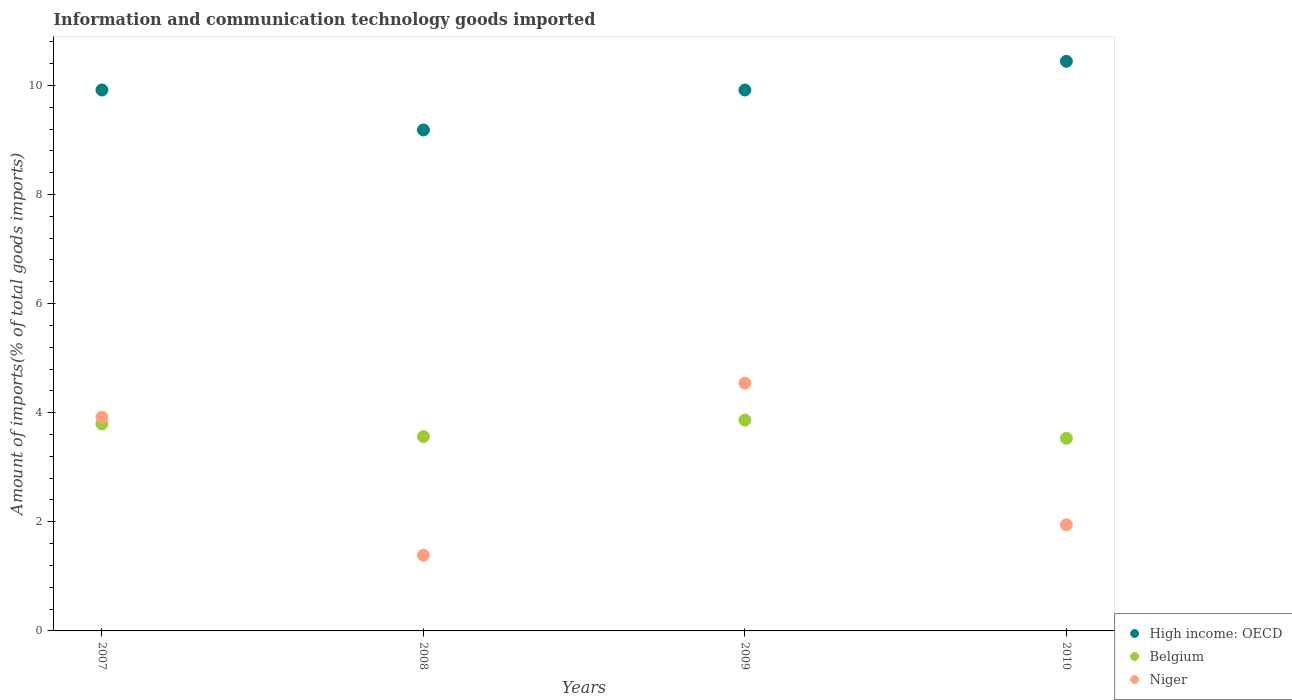How many different coloured dotlines are there?
Your answer should be very brief. 3. What is the amount of goods imported in Niger in 2008?
Ensure brevity in your answer.  1.39. Across all years, what is the maximum amount of goods imported in Niger?
Your answer should be compact. 4.54. Across all years, what is the minimum amount of goods imported in Belgium?
Provide a short and direct response. 3.53. In which year was the amount of goods imported in Belgium minimum?
Your answer should be compact. 2010. What is the total amount of goods imported in High income: OECD in the graph?
Make the answer very short. 39.46. What is the difference between the amount of goods imported in Niger in 2008 and that in 2010?
Make the answer very short. -0.56. What is the difference between the amount of goods imported in Niger in 2010 and the amount of goods imported in Belgium in 2007?
Keep it short and to the point. -1.85. What is the average amount of goods imported in Niger per year?
Ensure brevity in your answer.  2.95. In the year 2007, what is the difference between the amount of goods imported in High income: OECD and amount of goods imported in Belgium?
Your response must be concise. 6.12. In how many years, is the amount of goods imported in Belgium greater than 8.4 %?
Your response must be concise. 0. What is the ratio of the amount of goods imported in High income: OECD in 2007 to that in 2008?
Make the answer very short. 1.08. What is the difference between the highest and the second highest amount of goods imported in High income: OECD?
Keep it short and to the point. 0.53. What is the difference between the highest and the lowest amount of goods imported in Niger?
Your answer should be very brief. 3.15. Is the sum of the amount of goods imported in Belgium in 2007 and 2009 greater than the maximum amount of goods imported in High income: OECD across all years?
Ensure brevity in your answer.  No. Is it the case that in every year, the sum of the amount of goods imported in High income: OECD and amount of goods imported in Niger  is greater than the amount of goods imported in Belgium?
Your answer should be compact. Yes. Does the amount of goods imported in High income: OECD monotonically increase over the years?
Offer a very short reply. No. Is the amount of goods imported in Belgium strictly less than the amount of goods imported in High income: OECD over the years?
Ensure brevity in your answer.  Yes. What is the difference between two consecutive major ticks on the Y-axis?
Your response must be concise. 2. Are the values on the major ticks of Y-axis written in scientific E-notation?
Make the answer very short. No. Does the graph contain any zero values?
Your answer should be very brief. No. Where does the legend appear in the graph?
Offer a very short reply. Bottom right. How many legend labels are there?
Offer a terse response. 3. What is the title of the graph?
Keep it short and to the point. Information and communication technology goods imported. Does "Colombia" appear as one of the legend labels in the graph?
Offer a terse response. No. What is the label or title of the X-axis?
Your response must be concise. Years. What is the label or title of the Y-axis?
Offer a terse response. Amount of imports(% of total goods imports). What is the Amount of imports(% of total goods imports) in High income: OECD in 2007?
Your answer should be very brief. 9.92. What is the Amount of imports(% of total goods imports) of Belgium in 2007?
Offer a terse response. 3.79. What is the Amount of imports(% of total goods imports) in Niger in 2007?
Make the answer very short. 3.91. What is the Amount of imports(% of total goods imports) in High income: OECD in 2008?
Make the answer very short. 9.18. What is the Amount of imports(% of total goods imports) in Belgium in 2008?
Provide a short and direct response. 3.56. What is the Amount of imports(% of total goods imports) in Niger in 2008?
Give a very brief answer. 1.39. What is the Amount of imports(% of total goods imports) in High income: OECD in 2009?
Your answer should be very brief. 9.92. What is the Amount of imports(% of total goods imports) of Belgium in 2009?
Your answer should be compact. 3.87. What is the Amount of imports(% of total goods imports) of Niger in 2009?
Give a very brief answer. 4.54. What is the Amount of imports(% of total goods imports) of High income: OECD in 2010?
Your answer should be very brief. 10.44. What is the Amount of imports(% of total goods imports) in Belgium in 2010?
Provide a succinct answer. 3.53. What is the Amount of imports(% of total goods imports) in Niger in 2010?
Make the answer very short. 1.95. Across all years, what is the maximum Amount of imports(% of total goods imports) of High income: OECD?
Provide a succinct answer. 10.44. Across all years, what is the maximum Amount of imports(% of total goods imports) in Belgium?
Your answer should be compact. 3.87. Across all years, what is the maximum Amount of imports(% of total goods imports) in Niger?
Your response must be concise. 4.54. Across all years, what is the minimum Amount of imports(% of total goods imports) in High income: OECD?
Provide a short and direct response. 9.18. Across all years, what is the minimum Amount of imports(% of total goods imports) in Belgium?
Keep it short and to the point. 3.53. Across all years, what is the minimum Amount of imports(% of total goods imports) of Niger?
Provide a succinct answer. 1.39. What is the total Amount of imports(% of total goods imports) in High income: OECD in the graph?
Keep it short and to the point. 39.45. What is the total Amount of imports(% of total goods imports) of Belgium in the graph?
Your response must be concise. 14.75. What is the total Amount of imports(% of total goods imports) in Niger in the graph?
Make the answer very short. 11.79. What is the difference between the Amount of imports(% of total goods imports) in High income: OECD in 2007 and that in 2008?
Your response must be concise. 0.73. What is the difference between the Amount of imports(% of total goods imports) of Belgium in 2007 and that in 2008?
Provide a short and direct response. 0.23. What is the difference between the Amount of imports(% of total goods imports) in Niger in 2007 and that in 2008?
Give a very brief answer. 2.53. What is the difference between the Amount of imports(% of total goods imports) in Belgium in 2007 and that in 2009?
Ensure brevity in your answer.  -0.07. What is the difference between the Amount of imports(% of total goods imports) in Niger in 2007 and that in 2009?
Your answer should be very brief. -0.63. What is the difference between the Amount of imports(% of total goods imports) in High income: OECD in 2007 and that in 2010?
Ensure brevity in your answer.  -0.53. What is the difference between the Amount of imports(% of total goods imports) of Belgium in 2007 and that in 2010?
Ensure brevity in your answer.  0.26. What is the difference between the Amount of imports(% of total goods imports) of Niger in 2007 and that in 2010?
Ensure brevity in your answer.  1.97. What is the difference between the Amount of imports(% of total goods imports) of High income: OECD in 2008 and that in 2009?
Your response must be concise. -0.73. What is the difference between the Amount of imports(% of total goods imports) in Belgium in 2008 and that in 2009?
Ensure brevity in your answer.  -0.3. What is the difference between the Amount of imports(% of total goods imports) in Niger in 2008 and that in 2009?
Ensure brevity in your answer.  -3.15. What is the difference between the Amount of imports(% of total goods imports) in High income: OECD in 2008 and that in 2010?
Offer a very short reply. -1.26. What is the difference between the Amount of imports(% of total goods imports) of Belgium in 2008 and that in 2010?
Your answer should be very brief. 0.03. What is the difference between the Amount of imports(% of total goods imports) of Niger in 2008 and that in 2010?
Give a very brief answer. -0.56. What is the difference between the Amount of imports(% of total goods imports) in High income: OECD in 2009 and that in 2010?
Make the answer very short. -0.53. What is the difference between the Amount of imports(% of total goods imports) of Belgium in 2009 and that in 2010?
Ensure brevity in your answer.  0.33. What is the difference between the Amount of imports(% of total goods imports) in Niger in 2009 and that in 2010?
Make the answer very short. 2.6. What is the difference between the Amount of imports(% of total goods imports) in High income: OECD in 2007 and the Amount of imports(% of total goods imports) in Belgium in 2008?
Offer a very short reply. 6.35. What is the difference between the Amount of imports(% of total goods imports) of High income: OECD in 2007 and the Amount of imports(% of total goods imports) of Niger in 2008?
Provide a short and direct response. 8.53. What is the difference between the Amount of imports(% of total goods imports) of Belgium in 2007 and the Amount of imports(% of total goods imports) of Niger in 2008?
Offer a terse response. 2.41. What is the difference between the Amount of imports(% of total goods imports) of High income: OECD in 2007 and the Amount of imports(% of total goods imports) of Belgium in 2009?
Keep it short and to the point. 6.05. What is the difference between the Amount of imports(% of total goods imports) of High income: OECD in 2007 and the Amount of imports(% of total goods imports) of Niger in 2009?
Keep it short and to the point. 5.37. What is the difference between the Amount of imports(% of total goods imports) of Belgium in 2007 and the Amount of imports(% of total goods imports) of Niger in 2009?
Ensure brevity in your answer.  -0.75. What is the difference between the Amount of imports(% of total goods imports) of High income: OECD in 2007 and the Amount of imports(% of total goods imports) of Belgium in 2010?
Your answer should be very brief. 6.38. What is the difference between the Amount of imports(% of total goods imports) of High income: OECD in 2007 and the Amount of imports(% of total goods imports) of Niger in 2010?
Your answer should be very brief. 7.97. What is the difference between the Amount of imports(% of total goods imports) in Belgium in 2007 and the Amount of imports(% of total goods imports) in Niger in 2010?
Offer a terse response. 1.85. What is the difference between the Amount of imports(% of total goods imports) of High income: OECD in 2008 and the Amount of imports(% of total goods imports) of Belgium in 2009?
Ensure brevity in your answer.  5.32. What is the difference between the Amount of imports(% of total goods imports) of High income: OECD in 2008 and the Amount of imports(% of total goods imports) of Niger in 2009?
Your response must be concise. 4.64. What is the difference between the Amount of imports(% of total goods imports) of Belgium in 2008 and the Amount of imports(% of total goods imports) of Niger in 2009?
Provide a succinct answer. -0.98. What is the difference between the Amount of imports(% of total goods imports) in High income: OECD in 2008 and the Amount of imports(% of total goods imports) in Belgium in 2010?
Your answer should be compact. 5.65. What is the difference between the Amount of imports(% of total goods imports) in High income: OECD in 2008 and the Amount of imports(% of total goods imports) in Niger in 2010?
Your response must be concise. 7.24. What is the difference between the Amount of imports(% of total goods imports) of Belgium in 2008 and the Amount of imports(% of total goods imports) of Niger in 2010?
Ensure brevity in your answer.  1.62. What is the difference between the Amount of imports(% of total goods imports) in High income: OECD in 2009 and the Amount of imports(% of total goods imports) in Belgium in 2010?
Make the answer very short. 6.38. What is the difference between the Amount of imports(% of total goods imports) in High income: OECD in 2009 and the Amount of imports(% of total goods imports) in Niger in 2010?
Your answer should be very brief. 7.97. What is the difference between the Amount of imports(% of total goods imports) in Belgium in 2009 and the Amount of imports(% of total goods imports) in Niger in 2010?
Your answer should be very brief. 1.92. What is the average Amount of imports(% of total goods imports) of High income: OECD per year?
Keep it short and to the point. 9.86. What is the average Amount of imports(% of total goods imports) in Belgium per year?
Ensure brevity in your answer.  3.69. What is the average Amount of imports(% of total goods imports) in Niger per year?
Your answer should be compact. 2.95. In the year 2007, what is the difference between the Amount of imports(% of total goods imports) of High income: OECD and Amount of imports(% of total goods imports) of Belgium?
Offer a very short reply. 6.12. In the year 2007, what is the difference between the Amount of imports(% of total goods imports) of High income: OECD and Amount of imports(% of total goods imports) of Niger?
Provide a succinct answer. 6. In the year 2007, what is the difference between the Amount of imports(% of total goods imports) of Belgium and Amount of imports(% of total goods imports) of Niger?
Provide a succinct answer. -0.12. In the year 2008, what is the difference between the Amount of imports(% of total goods imports) of High income: OECD and Amount of imports(% of total goods imports) of Belgium?
Keep it short and to the point. 5.62. In the year 2008, what is the difference between the Amount of imports(% of total goods imports) of High income: OECD and Amount of imports(% of total goods imports) of Niger?
Offer a very short reply. 7.8. In the year 2008, what is the difference between the Amount of imports(% of total goods imports) in Belgium and Amount of imports(% of total goods imports) in Niger?
Give a very brief answer. 2.17. In the year 2009, what is the difference between the Amount of imports(% of total goods imports) of High income: OECD and Amount of imports(% of total goods imports) of Belgium?
Provide a succinct answer. 6.05. In the year 2009, what is the difference between the Amount of imports(% of total goods imports) of High income: OECD and Amount of imports(% of total goods imports) of Niger?
Keep it short and to the point. 5.37. In the year 2009, what is the difference between the Amount of imports(% of total goods imports) in Belgium and Amount of imports(% of total goods imports) in Niger?
Offer a very short reply. -0.68. In the year 2010, what is the difference between the Amount of imports(% of total goods imports) of High income: OECD and Amount of imports(% of total goods imports) of Belgium?
Give a very brief answer. 6.91. In the year 2010, what is the difference between the Amount of imports(% of total goods imports) in High income: OECD and Amount of imports(% of total goods imports) in Niger?
Provide a short and direct response. 8.5. In the year 2010, what is the difference between the Amount of imports(% of total goods imports) of Belgium and Amount of imports(% of total goods imports) of Niger?
Your answer should be very brief. 1.59. What is the ratio of the Amount of imports(% of total goods imports) of High income: OECD in 2007 to that in 2008?
Provide a succinct answer. 1.08. What is the ratio of the Amount of imports(% of total goods imports) in Belgium in 2007 to that in 2008?
Keep it short and to the point. 1.07. What is the ratio of the Amount of imports(% of total goods imports) of Niger in 2007 to that in 2008?
Your answer should be very brief. 2.82. What is the ratio of the Amount of imports(% of total goods imports) of High income: OECD in 2007 to that in 2009?
Make the answer very short. 1. What is the ratio of the Amount of imports(% of total goods imports) of Belgium in 2007 to that in 2009?
Offer a very short reply. 0.98. What is the ratio of the Amount of imports(% of total goods imports) in Niger in 2007 to that in 2009?
Offer a very short reply. 0.86. What is the ratio of the Amount of imports(% of total goods imports) in High income: OECD in 2007 to that in 2010?
Offer a very short reply. 0.95. What is the ratio of the Amount of imports(% of total goods imports) of Belgium in 2007 to that in 2010?
Offer a very short reply. 1.07. What is the ratio of the Amount of imports(% of total goods imports) in Niger in 2007 to that in 2010?
Keep it short and to the point. 2.01. What is the ratio of the Amount of imports(% of total goods imports) in High income: OECD in 2008 to that in 2009?
Provide a short and direct response. 0.93. What is the ratio of the Amount of imports(% of total goods imports) of Belgium in 2008 to that in 2009?
Offer a very short reply. 0.92. What is the ratio of the Amount of imports(% of total goods imports) in Niger in 2008 to that in 2009?
Ensure brevity in your answer.  0.31. What is the ratio of the Amount of imports(% of total goods imports) of High income: OECD in 2008 to that in 2010?
Provide a succinct answer. 0.88. What is the ratio of the Amount of imports(% of total goods imports) of Belgium in 2008 to that in 2010?
Keep it short and to the point. 1.01. What is the ratio of the Amount of imports(% of total goods imports) in Niger in 2008 to that in 2010?
Provide a short and direct response. 0.71. What is the ratio of the Amount of imports(% of total goods imports) of High income: OECD in 2009 to that in 2010?
Keep it short and to the point. 0.95. What is the ratio of the Amount of imports(% of total goods imports) in Belgium in 2009 to that in 2010?
Provide a short and direct response. 1.09. What is the ratio of the Amount of imports(% of total goods imports) of Niger in 2009 to that in 2010?
Your answer should be compact. 2.33. What is the difference between the highest and the second highest Amount of imports(% of total goods imports) of High income: OECD?
Provide a short and direct response. 0.53. What is the difference between the highest and the second highest Amount of imports(% of total goods imports) in Belgium?
Keep it short and to the point. 0.07. What is the difference between the highest and the second highest Amount of imports(% of total goods imports) of Niger?
Offer a terse response. 0.63. What is the difference between the highest and the lowest Amount of imports(% of total goods imports) of High income: OECD?
Your response must be concise. 1.26. What is the difference between the highest and the lowest Amount of imports(% of total goods imports) in Belgium?
Ensure brevity in your answer.  0.33. What is the difference between the highest and the lowest Amount of imports(% of total goods imports) of Niger?
Keep it short and to the point. 3.15. 